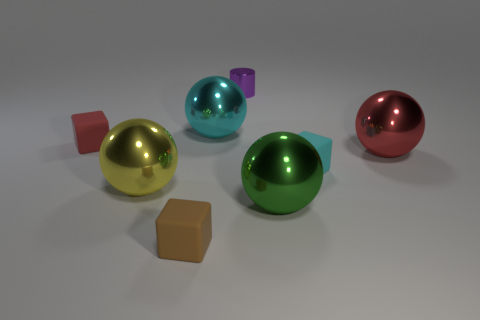There is a matte cube that is on the right side of the purple metal thing; what is its color?
Offer a terse response. Cyan. What is the size of the red ball that is made of the same material as the green sphere?
Your answer should be compact. Large. Do the cylinder and the red object on the left side of the big red metal thing have the same size?
Give a very brief answer. Yes. What material is the red thing that is on the left side of the tiny purple cylinder?
Provide a succinct answer. Rubber. How many small matte blocks are to the left of the matte thing in front of the cyan rubber object?
Your answer should be compact. 1. Are there any large yellow shiny things of the same shape as the cyan matte object?
Your response must be concise. No. Does the metallic thing that is behind the cyan metal ball have the same size as the matte block on the right side of the tiny brown rubber object?
Offer a terse response. Yes. What is the shape of the rubber object that is on the right side of the tiny purple shiny cylinder that is left of the green object?
Make the answer very short. Cube. How many gray metal balls are the same size as the cyan matte object?
Keep it short and to the point. 0. Is there a big gray metal cylinder?
Provide a short and direct response. No. 